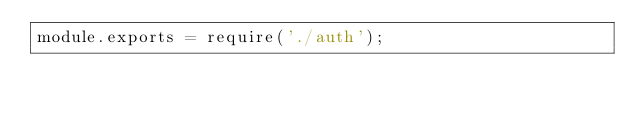<code> <loc_0><loc_0><loc_500><loc_500><_JavaScript_>module.exports = require('./auth');</code> 